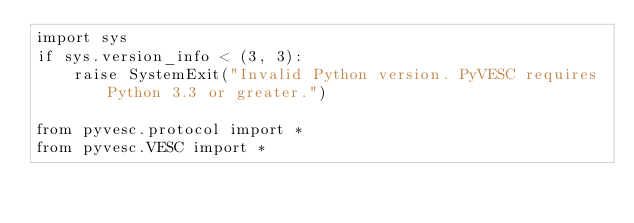Convert code to text. <code><loc_0><loc_0><loc_500><loc_500><_Python_>import sys
if sys.version_info < (3, 3):
    raise SystemExit("Invalid Python version. PyVESC requires Python 3.3 or greater.")

from pyvesc.protocol import *
from pyvesc.VESC import *
</code> 